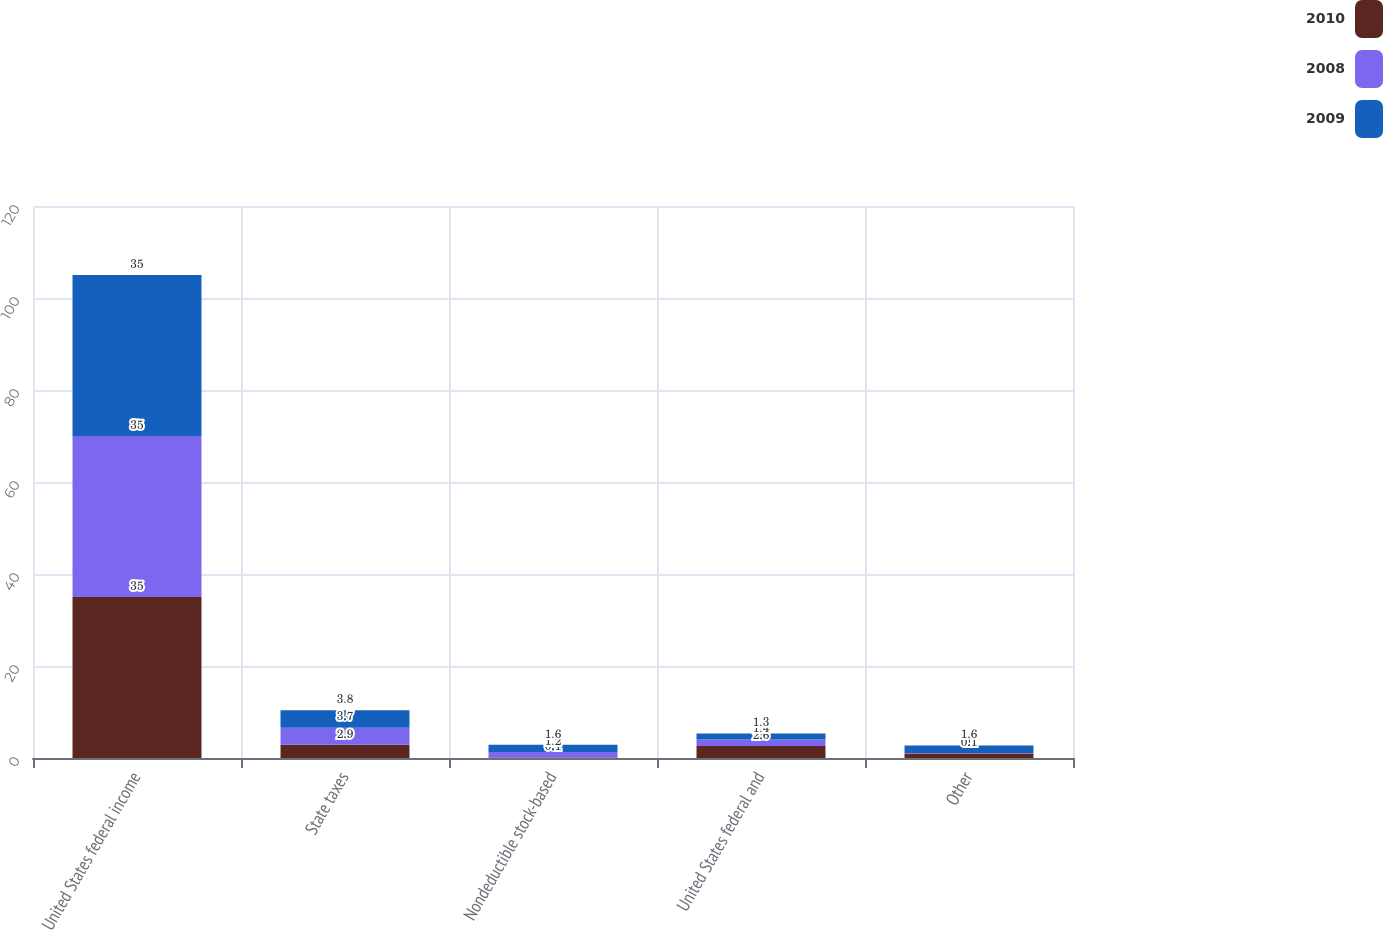Convert chart to OTSL. <chart><loc_0><loc_0><loc_500><loc_500><stacked_bar_chart><ecel><fcel>United States federal income<fcel>State taxes<fcel>Nondeductible stock-based<fcel>United States federal and<fcel>Other<nl><fcel>2010<fcel>35<fcel>2.9<fcel>0.1<fcel>2.6<fcel>1<nl><fcel>2008<fcel>35<fcel>3.7<fcel>1.2<fcel>1.4<fcel>0.1<nl><fcel>2009<fcel>35<fcel>3.8<fcel>1.6<fcel>1.3<fcel>1.6<nl></chart> 